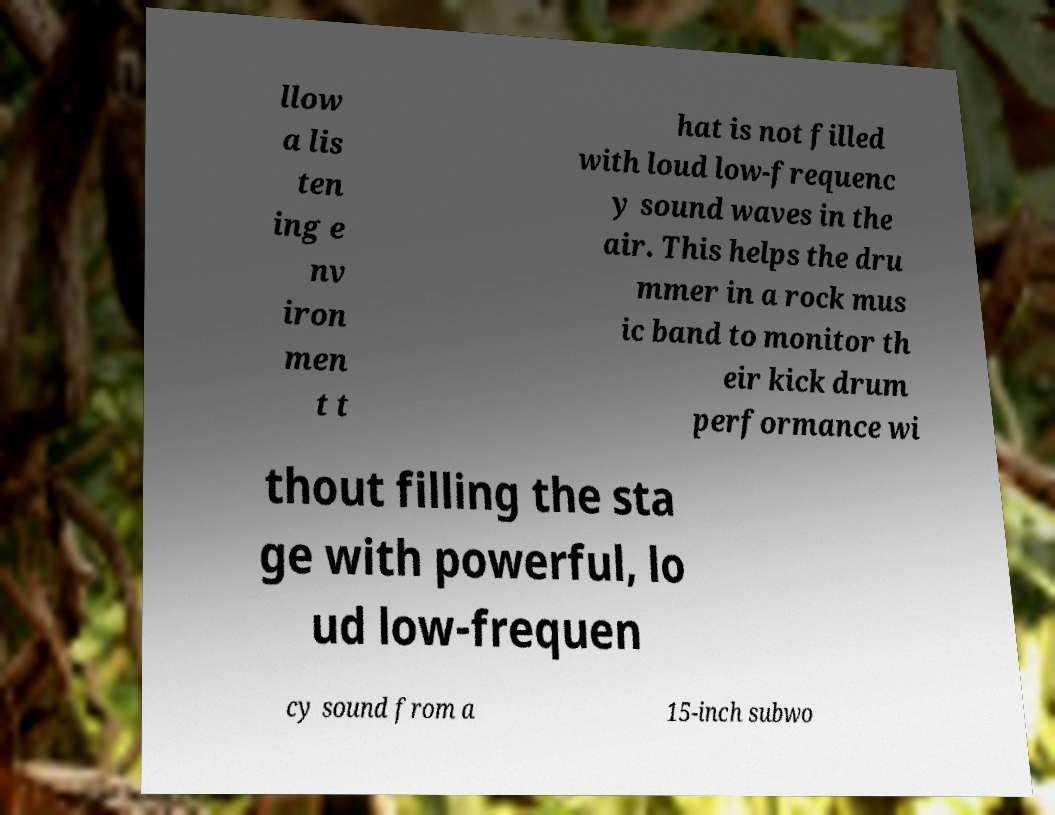Can you read and provide the text displayed in the image?This photo seems to have some interesting text. Can you extract and type it out for me? llow a lis ten ing e nv iron men t t hat is not filled with loud low-frequenc y sound waves in the air. This helps the dru mmer in a rock mus ic band to monitor th eir kick drum performance wi thout filling the sta ge with powerful, lo ud low-frequen cy sound from a 15-inch subwo 